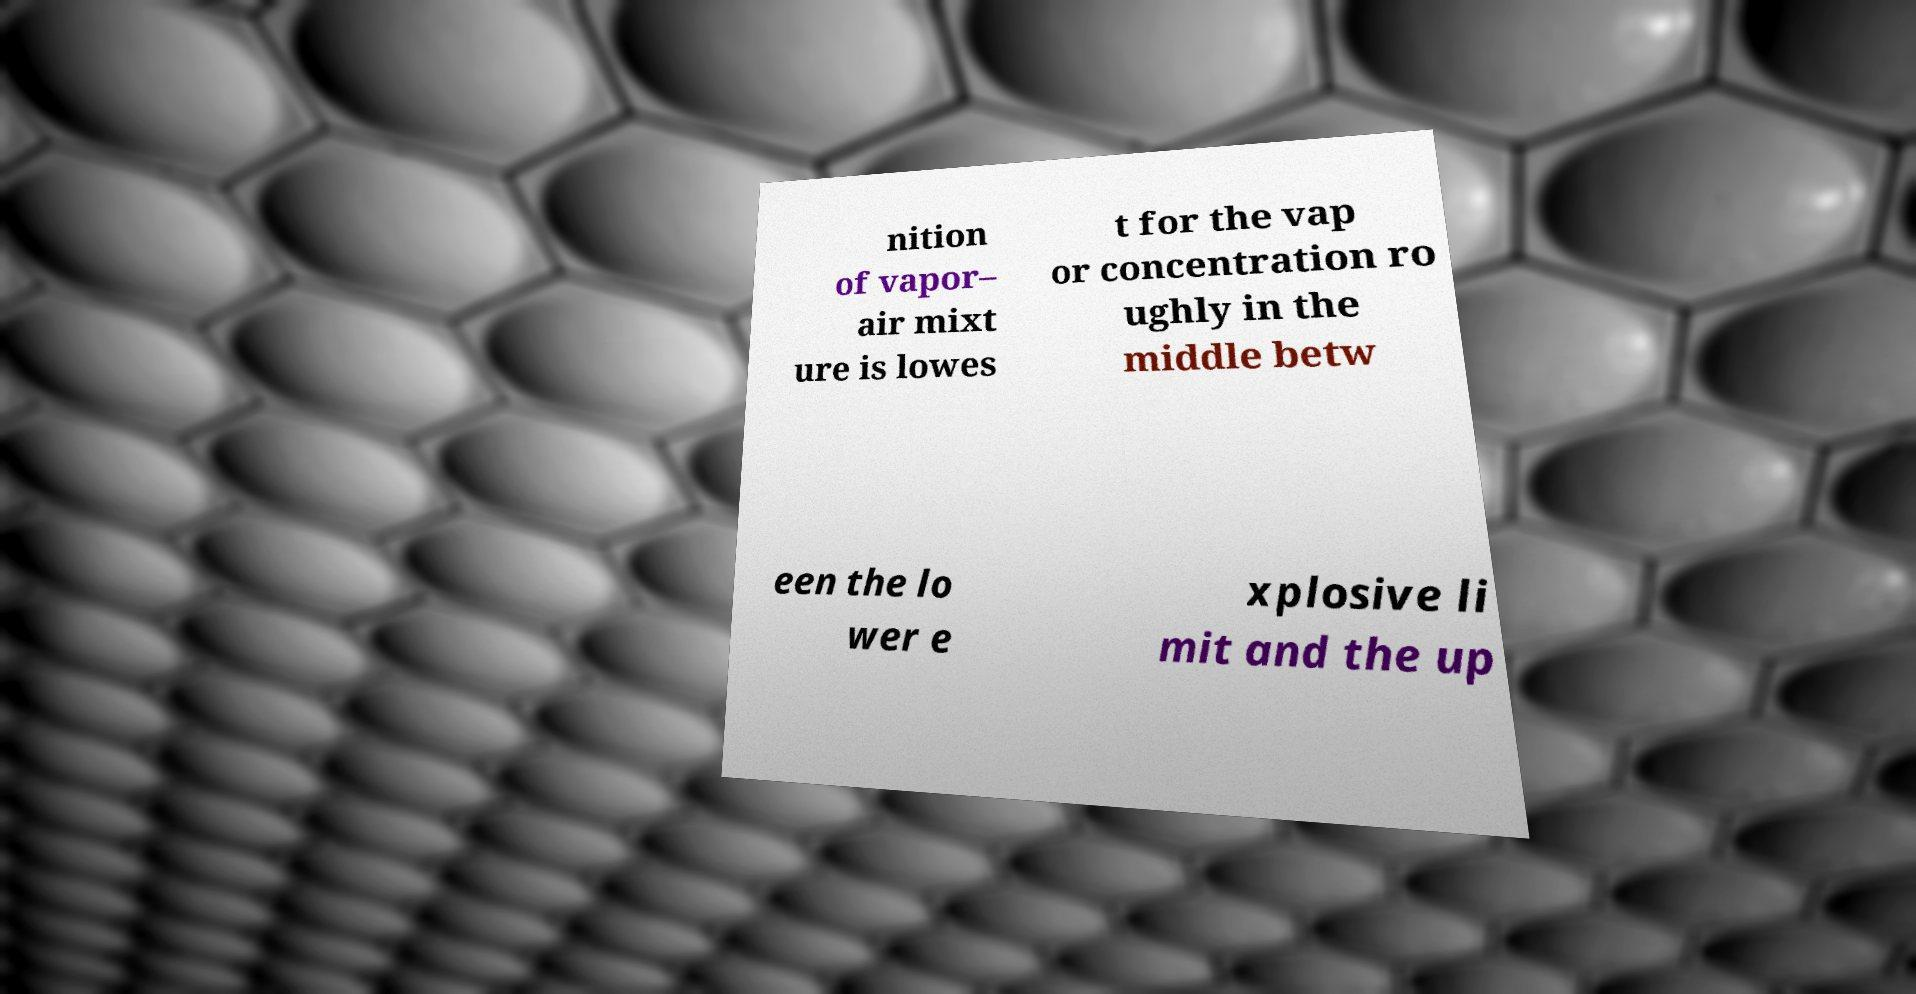Could you assist in decoding the text presented in this image and type it out clearly? nition of vapor– air mixt ure is lowes t for the vap or concentration ro ughly in the middle betw een the lo wer e xplosive li mit and the up 